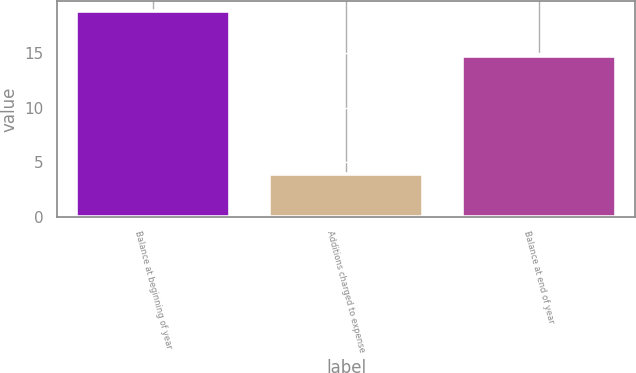Convert chart. <chart><loc_0><loc_0><loc_500><loc_500><bar_chart><fcel>Balance at beginning of year<fcel>Additions charged to expense<fcel>Balance at end of year<nl><fcel>18.8<fcel>3.9<fcel>14.7<nl></chart> 